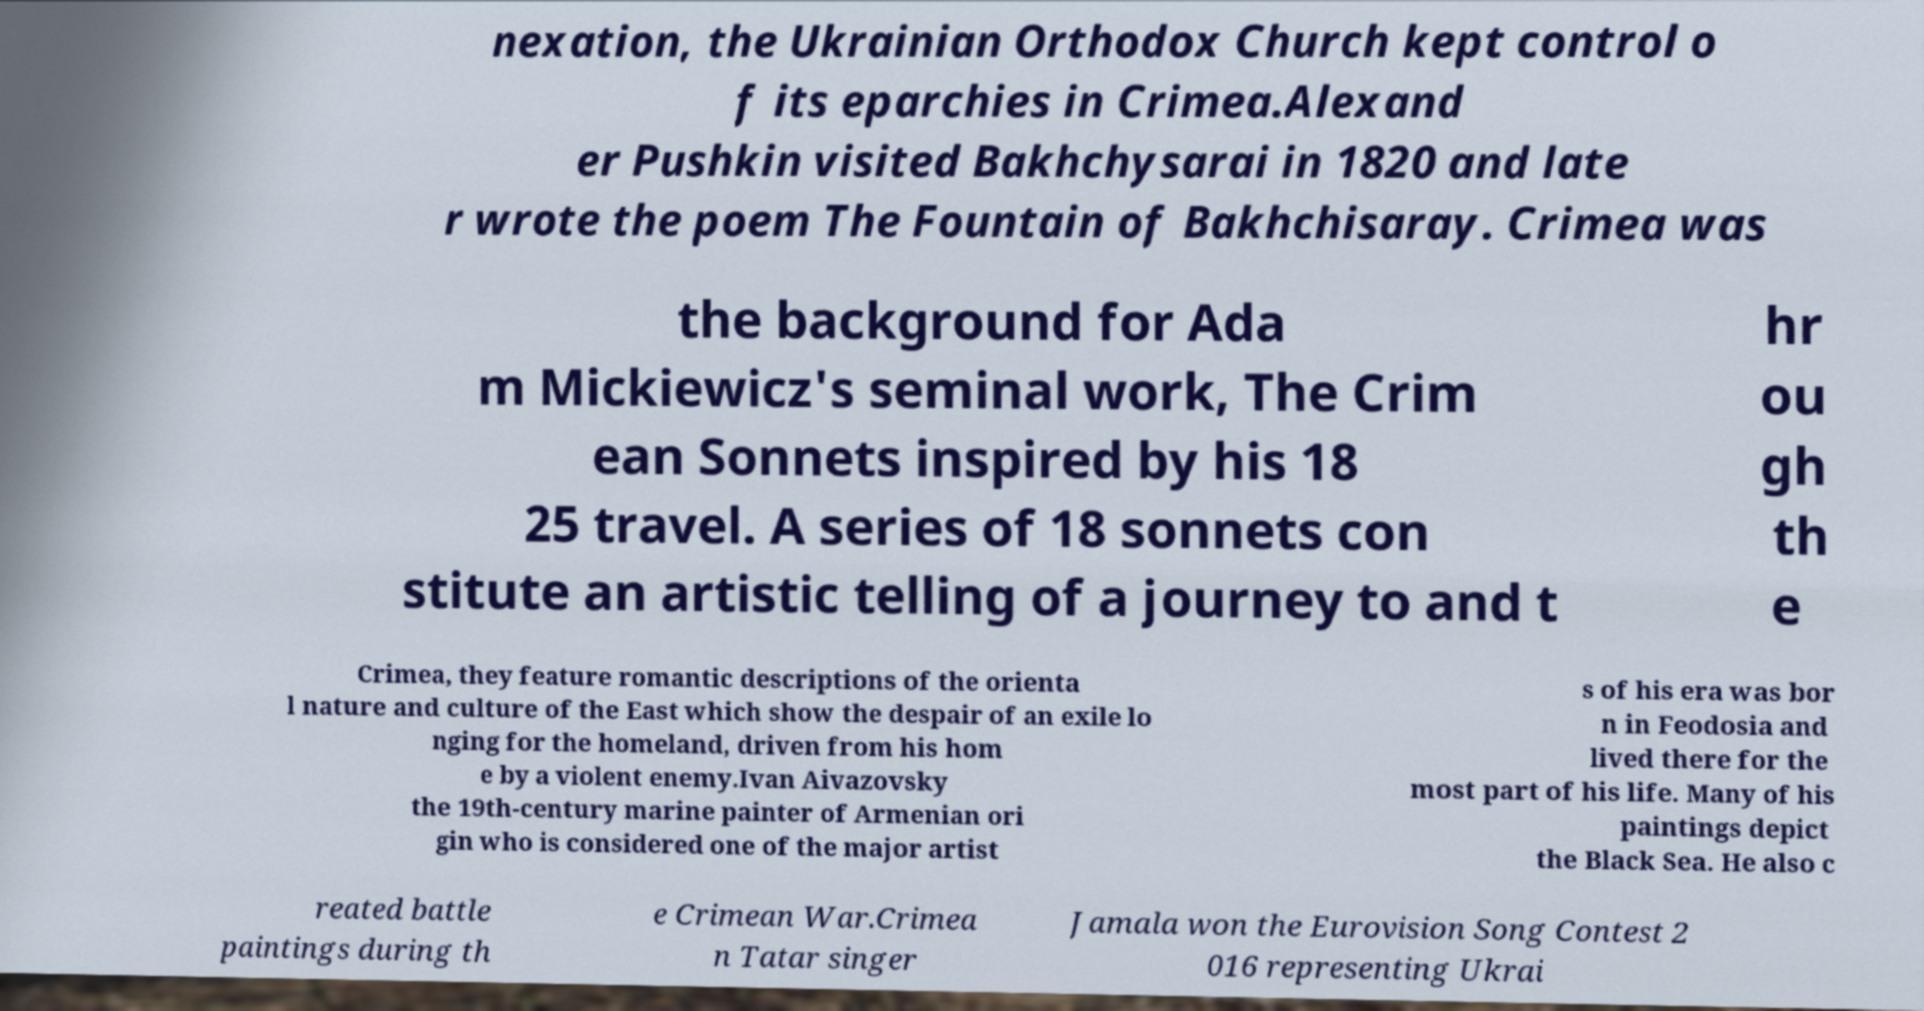For documentation purposes, I need the text within this image transcribed. Could you provide that? nexation, the Ukrainian Orthodox Church kept control o f its eparchies in Crimea.Alexand er Pushkin visited Bakhchysarai in 1820 and late r wrote the poem The Fountain of Bakhchisaray. Crimea was the background for Ada m Mickiewicz's seminal work, The Crim ean Sonnets inspired by his 18 25 travel. A series of 18 sonnets con stitute an artistic telling of a journey to and t hr ou gh th e Crimea, they feature romantic descriptions of the orienta l nature and culture of the East which show the despair of an exile lo nging for the homeland, driven from his hom e by a violent enemy.Ivan Aivazovsky the 19th-century marine painter of Armenian ori gin who is considered one of the major artist s of his era was bor n in Feodosia and lived there for the most part of his life. Many of his paintings depict the Black Sea. He also c reated battle paintings during th e Crimean War.Crimea n Tatar singer Jamala won the Eurovision Song Contest 2 016 representing Ukrai 